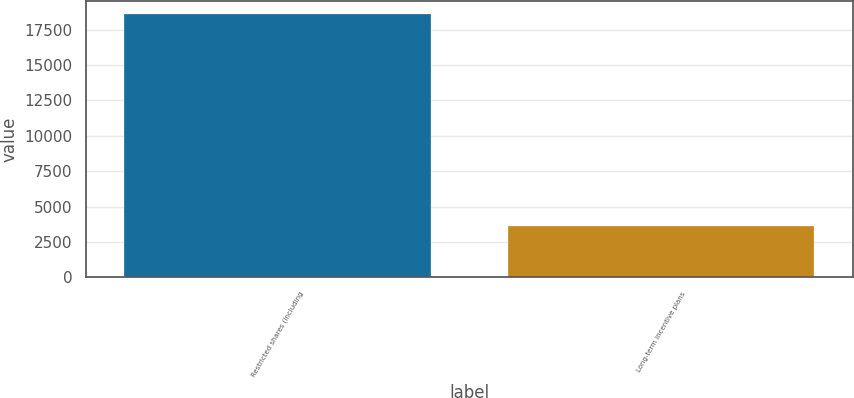Convert chart. <chart><loc_0><loc_0><loc_500><loc_500><bar_chart><fcel>Restricted shares (including<fcel>Long-term incentive plans<nl><fcel>18626<fcel>3602<nl></chart> 